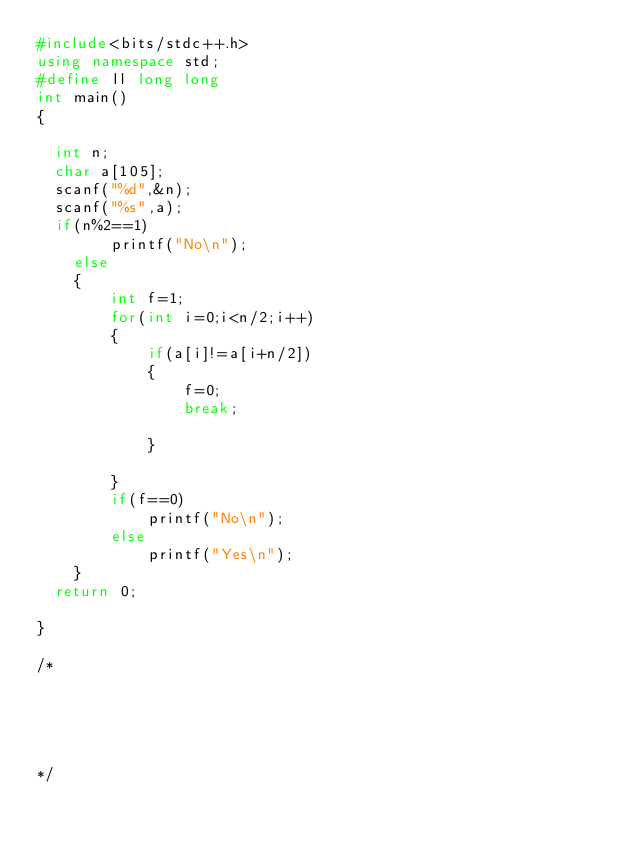Convert code to text. <code><loc_0><loc_0><loc_500><loc_500><_C++_>#include<bits/stdc++.h>
using namespace std;
#define ll long long
int main()
{

	int n;
	char a[105];
	scanf("%d",&n);
	scanf("%s",a);
	if(n%2==1)
        printf("No\n");
    else
    {
        int f=1;
        for(int i=0;i<n/2;i++)
        {
            if(a[i]!=a[i+n/2])
            {
                f=0;
                break;

            }

        }
        if(f==0)
            printf("No\n");
        else
            printf("Yes\n");
    }
	return 0;

}

/*





*/
</code> 